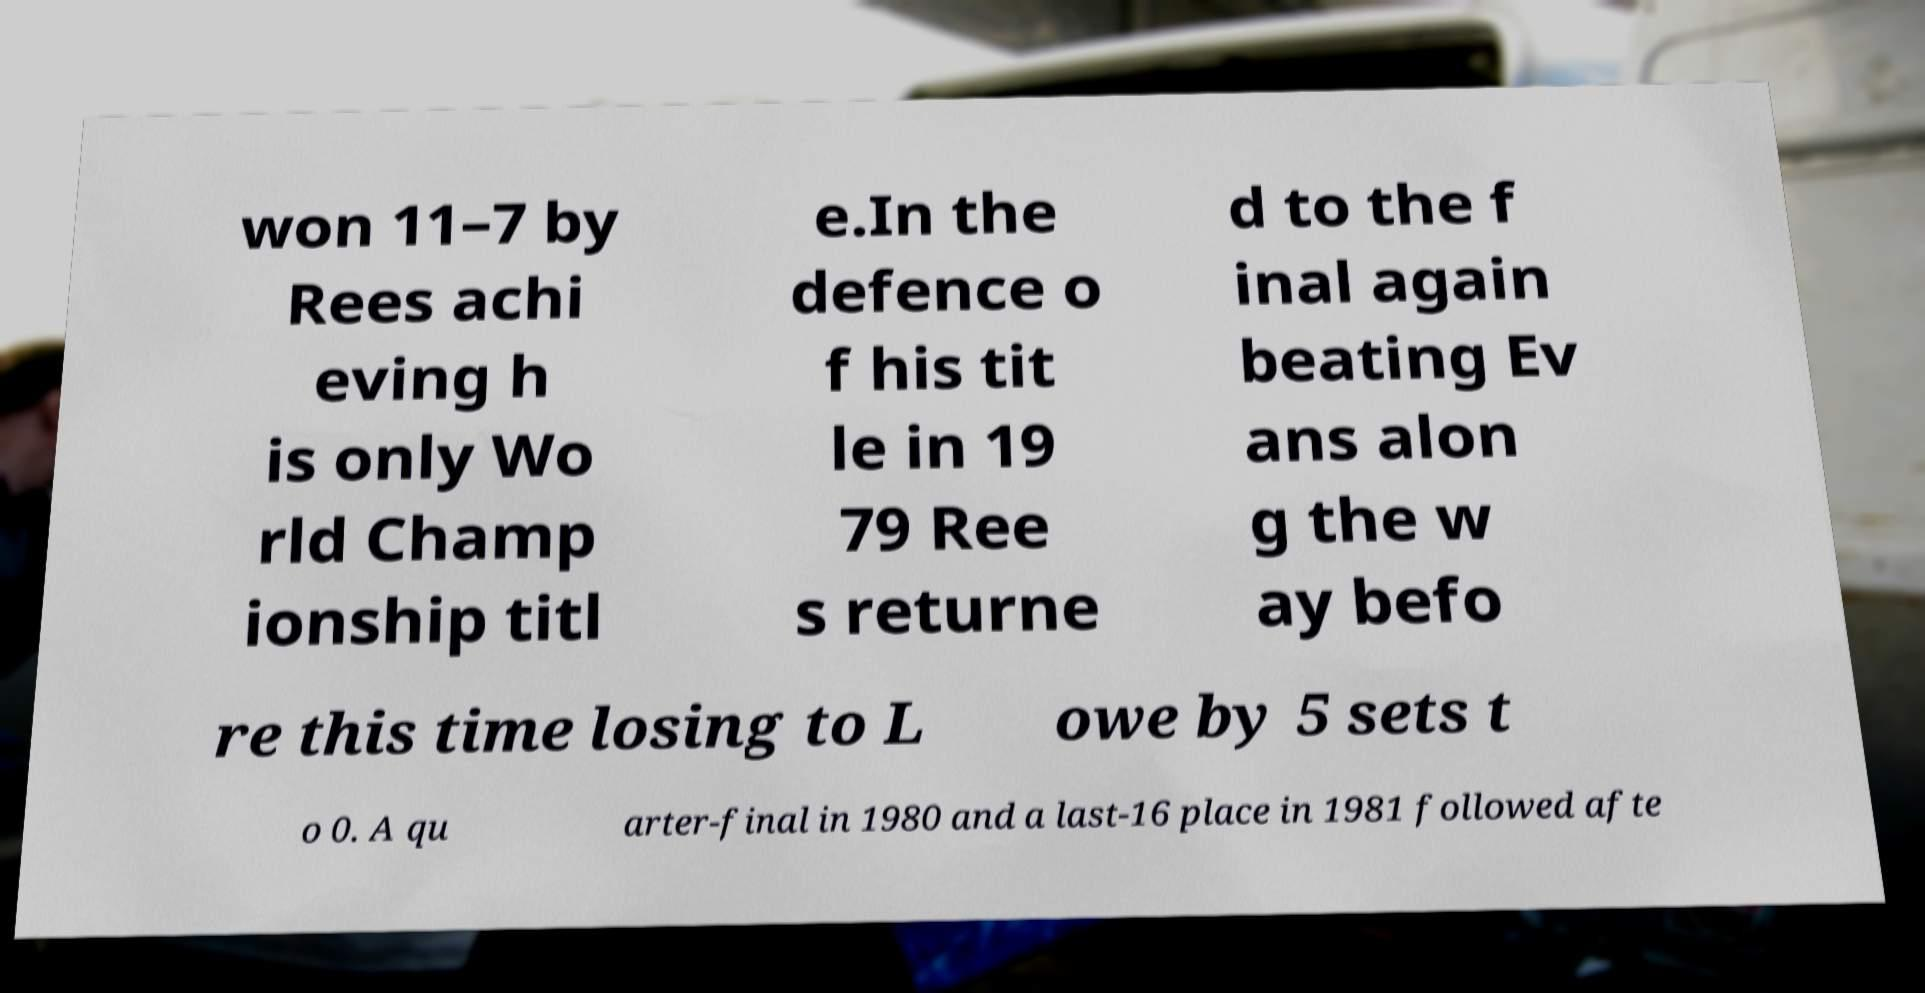Please identify and transcribe the text found in this image. won 11–7 by Rees achi eving h is only Wo rld Champ ionship titl e.In the defence o f his tit le in 19 79 Ree s returne d to the f inal again beating Ev ans alon g the w ay befo re this time losing to L owe by 5 sets t o 0. A qu arter-final in 1980 and a last-16 place in 1981 followed afte 